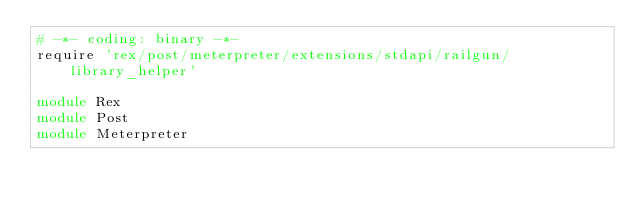<code> <loc_0><loc_0><loc_500><loc_500><_Ruby_># -*- coding: binary -*-
require 'rex/post/meterpreter/extensions/stdapi/railgun/library_helper'

module Rex
module Post
module Meterpreter</code> 